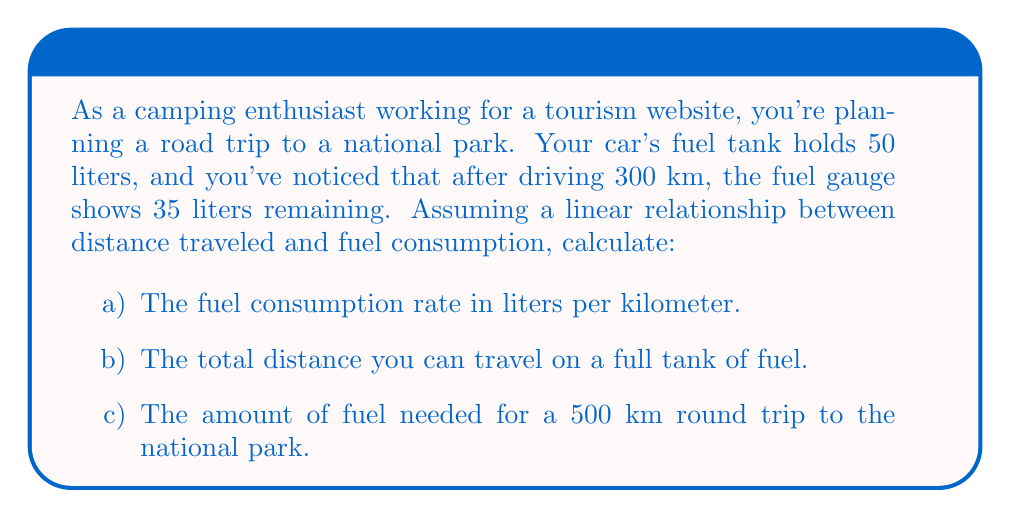Can you answer this question? Let's approach this step-by-step using linear equations:

a) To find the fuel consumption rate, we need to determine how much fuel was used and divide it by the distance traveled.

Fuel used = Initial fuel - Remaining fuel
$$ 50L - 35L = 15L $$

Fuel consumption rate = Fuel used ÷ Distance traveled
$$ \text{Rate} = \frac{15L}{300km} = 0.05 L/km $$

b) To find the total distance on a full tank, we can use the linear equation:
$$ y = mx + b $$
Where:
$y$ is the fuel remaining
$m$ is the fuel consumption rate (negative, as fuel decreases)
$x$ is the distance traveled
$b$ is the initial fuel amount

$$ y = -0.05x + 50 $$

To find the maximum distance, set $y = 0$ and solve for $x$:

$$ 0 = -0.05x + 50 $$
$$ 0.05x = 50 $$
$$ x = \frac{50}{0.05} = 1000 km $$

c) For a 500 km round trip, we can use the fuel consumption rate:

Fuel needed = Rate × Distance
$$ \text{Fuel needed} = 0.05 L/km \times 500 km = 25L $$
Answer: a) The fuel consumption rate is $0.05 L/km$.
b) The total distance that can be traveled on a full tank is $1000 km$.
c) The amount of fuel needed for a 500 km round trip is $25 L$. 